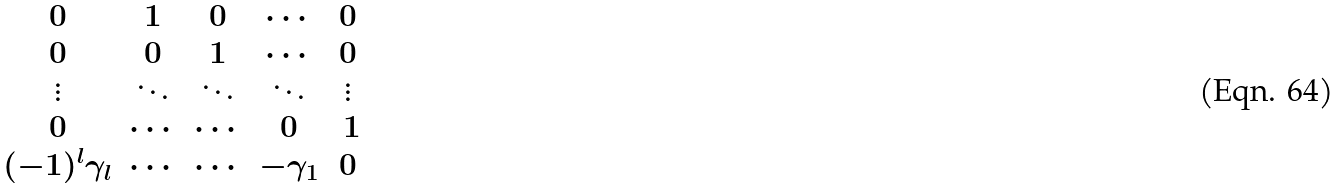<formula> <loc_0><loc_0><loc_500><loc_500>\begin{matrix} 0 & 1 & 0 & \cdots & 0 \\ 0 & 0 & 1 & \cdots & 0 \\ \vdots & \ddots & \ddots & \ddots & \vdots \\ 0 & \cdots & \cdots & 0 & \ 1 \\ ( - 1 ) ^ { l } { \gamma } _ { l } & \cdots & \cdots & - { \gamma } _ { 1 } & 0 \\ \end{matrix}</formula> 